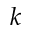Convert formula to latex. <formula><loc_0><loc_0><loc_500><loc_500>k</formula> 